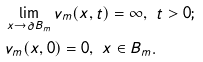<formula> <loc_0><loc_0><loc_500><loc_500>& \lim _ { x \to \partial B _ { m } } v _ { m } ( x , t ) = \infty , \ t > 0 ; \\ & v _ { m } ( x , 0 ) = 0 , \ x \in B _ { m } .</formula> 